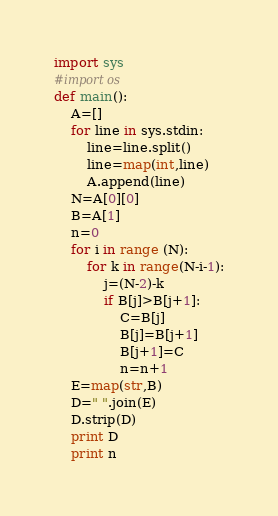Convert code to text. <code><loc_0><loc_0><loc_500><loc_500><_Python_>import sys
#import os
def main():
    A=[]
    for line in sys.stdin:
        line=line.split()
        line=map(int,line)
        A.append(line)
    N=A[0][0]
    B=A[1]
    n=0
    for i in range (N):
        for k in range(N-i-1):
            j=(N-2)-k
            if B[j]>B[j+1]:
                C=B[j]
                B[j]=B[j+1]
                B[j+1]=C
                n=n+1
    E=map(str,B)
    D=" ".join(E)
    D.strip(D)
    print D 
    print n</code> 